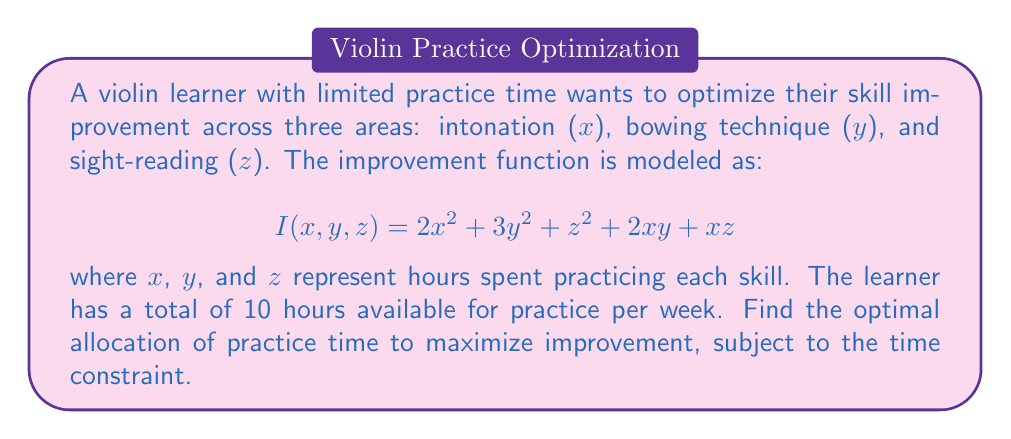Could you help me with this problem? To solve this optimization problem with constraints, we'll use the method of Lagrange multipliers.

1) First, we set up the constraint equation:
   $$x + y + z = 10$$

2) Now, we form the Lagrangian function:
   $$L(x,y,z,\lambda) = I(x,y,z) - \lambda(x + y + z - 10)$$
   $$L(x,y,z,\lambda) = 2x^2 + 3y^2 + z^2 + 2xy + xz - \lambda(x + y + z - 10)$$

3) We take partial derivatives and set them equal to zero:

   $$\frac{\partial L}{\partial x} = 4x + 2y + z - \lambda = 0$$
   $$\frac{\partial L}{\partial y} = 6y + 2x - \lambda = 0$$
   $$\frac{\partial L}{\partial z} = 2z + x - \lambda = 0$$
   $$\frac{\partial L}{\partial \lambda} = x + y + z - 10 = 0$$

4) From these equations, we can derive:
   
   From (2): $y = \frac{\lambda - 2x}{6}$
   From (3): $z = \frac{\lambda - x}{2}$

5) Substituting these into (4):

   $$x + \frac{\lambda - 2x}{6} + \frac{\lambda - x}{2} = 10$$

6) Simplifying:

   $$6x + \lambda - 2x + 3\lambda - 3x = 60$$
   $$x + 4\lambda = 60$$

7) Substituting this into (1):

   $$4x + 2(\frac{\lambda - 2x}{6}) + (\frac{\lambda - x}{2}) = \lambda$$
   
   Simplifying:
   $$24x + 2\lambda - 4x + 3\lambda - 3x = 6\lambda$$
   $$17x = \lambda$$

8) Using the results from (6) and (7):

   $$17x = 60 - x$$
   $$18x = 60$$
   $$x = \frac{10}{3}$$

9) We can now solve for y and z:

   $$y = \frac{\lambda - 2x}{6} = \frac{60 - 4x}{6} = \frac{60 - 40/3}{6} = \frac{10}{3}$$
   $$z = \frac{\lambda - x}{2} = \frac{60 - 11x}{2} = \frac{60 - 110/3}{2} = \frac{10}{3}$$

Therefore, the optimal allocation of practice time is $\frac{10}{3}$ hours for each skill.
Answer: The optimal allocation of practice time is $\frac{10}{3}$ hours (approximately 3.33 hours) for each of intonation, bowing technique, and sight-reading. 